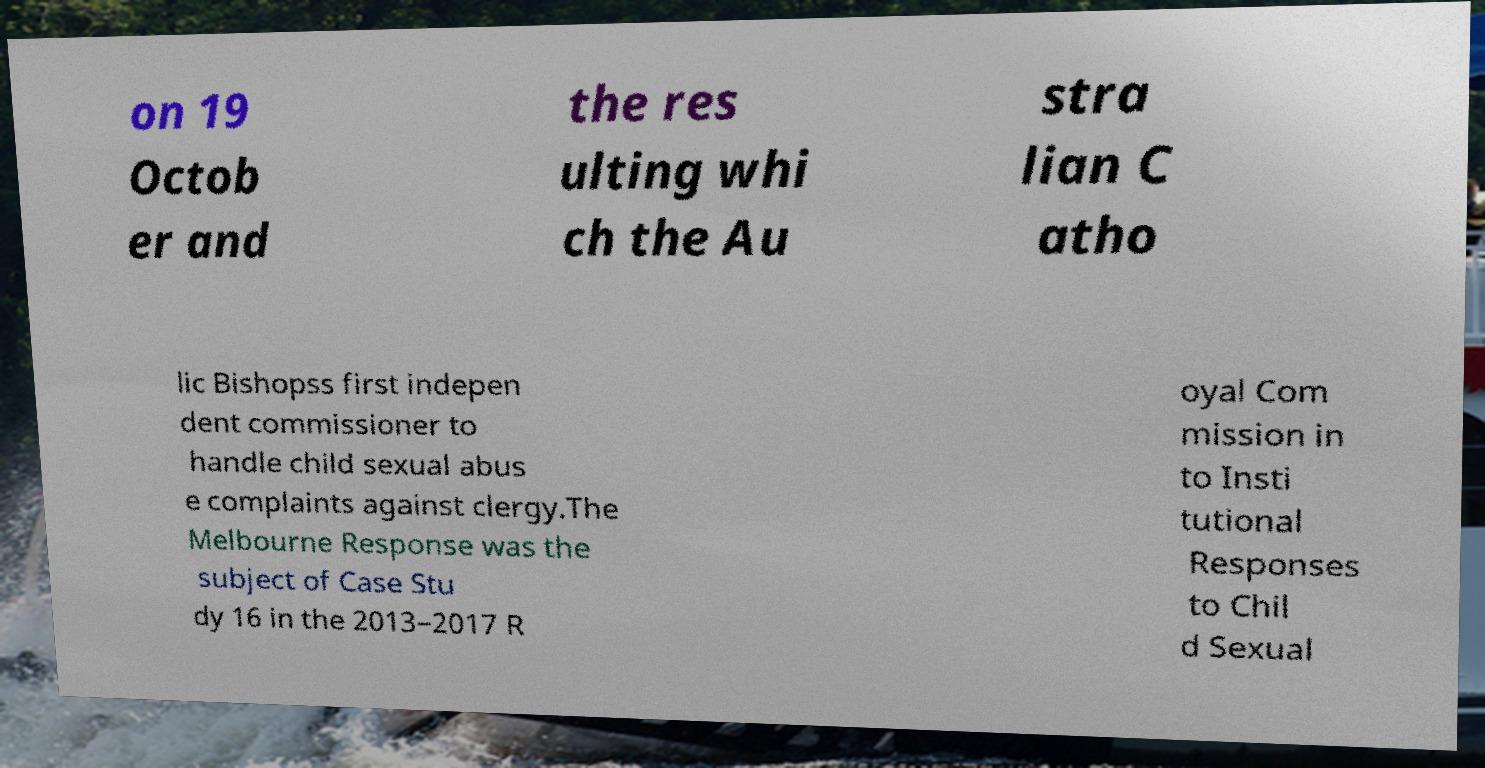Can you accurately transcribe the text from the provided image for me? on 19 Octob er and the res ulting whi ch the Au stra lian C atho lic Bishopss first indepen dent commissioner to handle child sexual abus e complaints against clergy.The Melbourne Response was the subject of Case Stu dy 16 in the 2013–2017 R oyal Com mission in to Insti tutional Responses to Chil d Sexual 